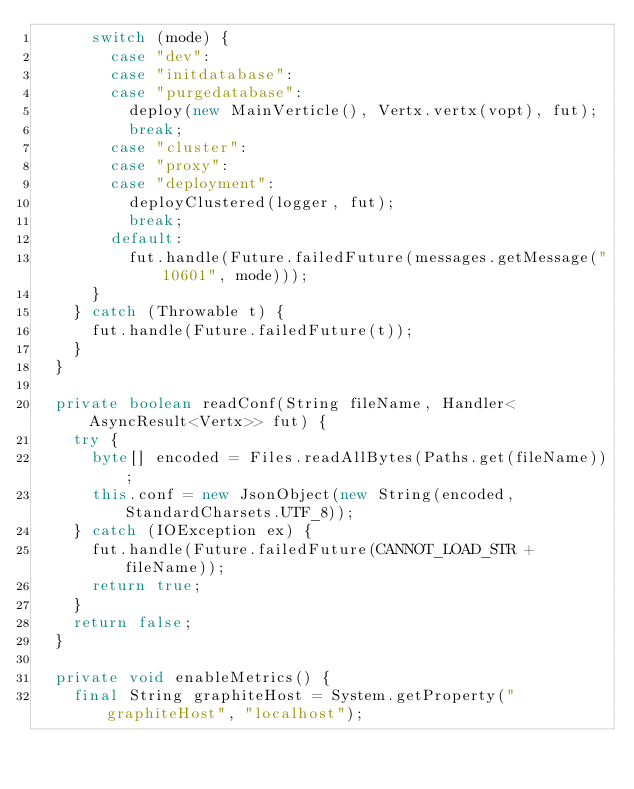Convert code to text. <code><loc_0><loc_0><loc_500><loc_500><_Java_>      switch (mode) {
        case "dev":
        case "initdatabase":
        case "purgedatabase":
          deploy(new MainVerticle(), Vertx.vertx(vopt), fut);
          break;
        case "cluster":
        case "proxy":
        case "deployment":
          deployClustered(logger, fut);
          break;
        default:
          fut.handle(Future.failedFuture(messages.getMessage("10601", mode)));
      }
    } catch (Throwable t) {
      fut.handle(Future.failedFuture(t));
    }
  }

  private boolean readConf(String fileName, Handler<AsyncResult<Vertx>> fut) {
    try {
      byte[] encoded = Files.readAllBytes(Paths.get(fileName));
      this.conf = new JsonObject(new String(encoded, StandardCharsets.UTF_8));
    } catch (IOException ex) {
      fut.handle(Future.failedFuture(CANNOT_LOAD_STR + fileName));
      return true;
    }
    return false;
  }

  private void enableMetrics() {
    final String graphiteHost = System.getProperty("graphiteHost", "localhost");</code> 